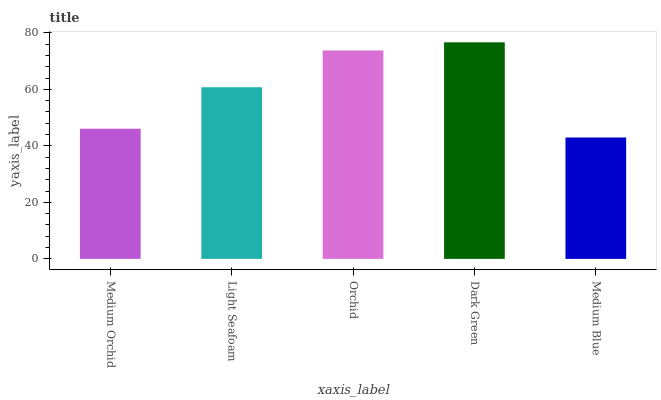Is Medium Blue the minimum?
Answer yes or no. Yes. Is Dark Green the maximum?
Answer yes or no. Yes. Is Light Seafoam the minimum?
Answer yes or no. No. Is Light Seafoam the maximum?
Answer yes or no. No. Is Light Seafoam greater than Medium Orchid?
Answer yes or no. Yes. Is Medium Orchid less than Light Seafoam?
Answer yes or no. Yes. Is Medium Orchid greater than Light Seafoam?
Answer yes or no. No. Is Light Seafoam less than Medium Orchid?
Answer yes or no. No. Is Light Seafoam the high median?
Answer yes or no. Yes. Is Light Seafoam the low median?
Answer yes or no. Yes. Is Medium Blue the high median?
Answer yes or no. No. Is Medium Orchid the low median?
Answer yes or no. No. 